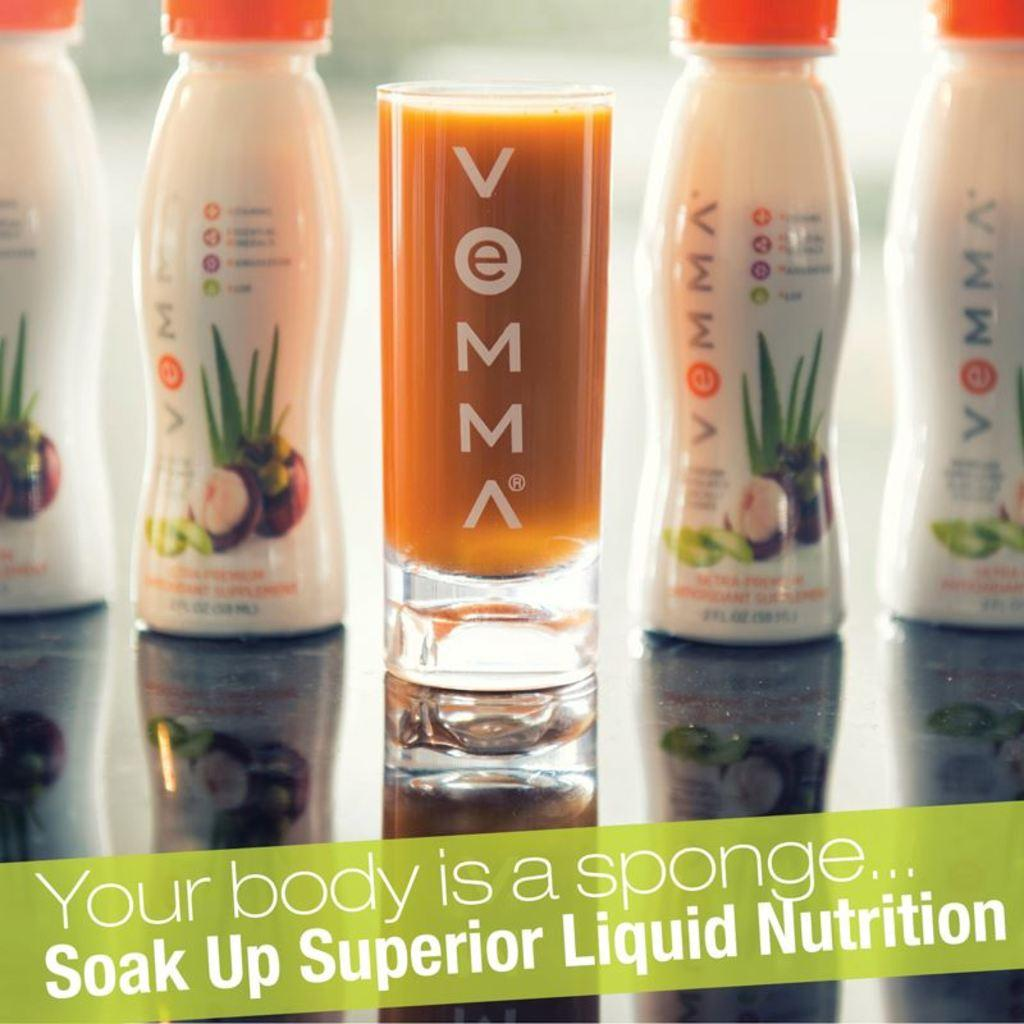<image>
Create a compact narrative representing the image presented. A bottle of Vemma and a full glass of an orange liquid. 